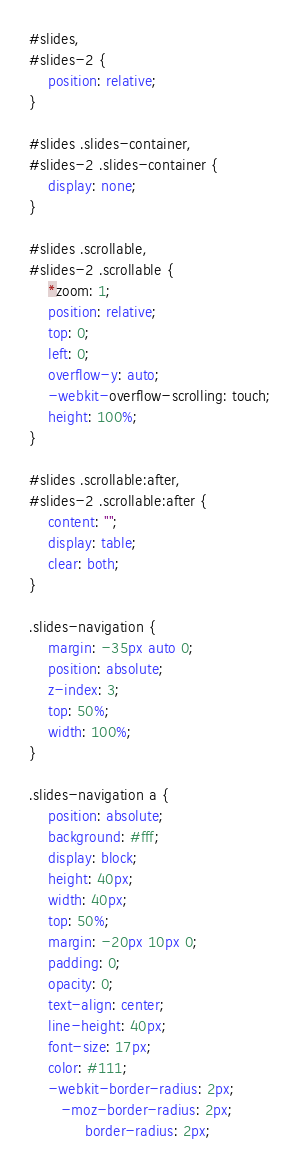Convert code to text. <code><loc_0><loc_0><loc_500><loc_500><_CSS_>#slides,
#slides-2 {
	position: relative;
}

#slides .slides-container,
#slides-2 .slides-container {
	display: none;
}

#slides .scrollable,
#slides-2 .scrollable {
	*zoom: 1;
	position: relative;
	top: 0;
	left: 0;
	overflow-y: auto;
	-webkit-overflow-scrolling: touch;
	height: 100%;
}

#slides .scrollable:after,
#slides-2 .scrollable:after {
	content: "";
	display: table;
	clear: both;
}

.slides-navigation {
	margin: -35px auto 0;
	position: absolute;
	z-index: 3;
	top: 50%;
	width: 100%;
}

.slides-navigation a {
	position: absolute;
	background: #fff;
	display: block;
	height: 40px;
	width: 40px;
	top: 50%;
	margin: -20px 10px 0;
	padding: 0;
	opacity: 0;
	text-align: center;
	line-height: 40px;
	font-size: 17px;
	color: #111;
	-webkit-border-radius: 2px;
	   -moz-border-radius: 2px;
	        border-radius: 2px;</code> 